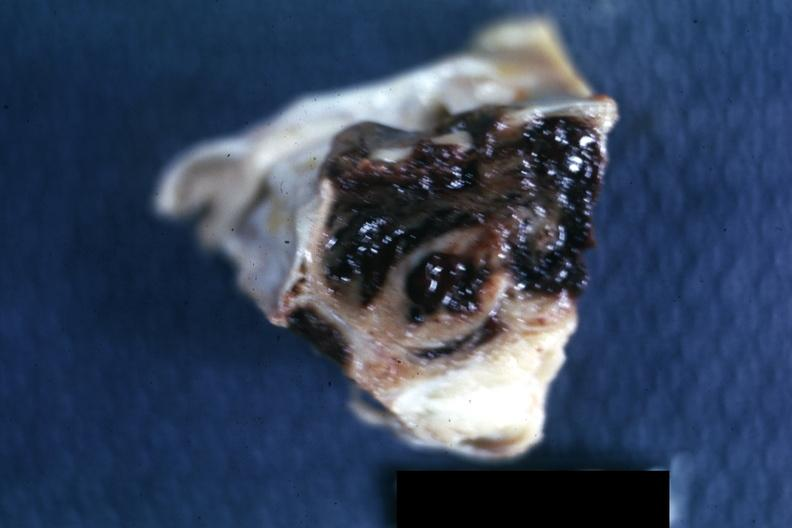where does this belong to?
Answer the question using a single word or phrase. Endocrine system 